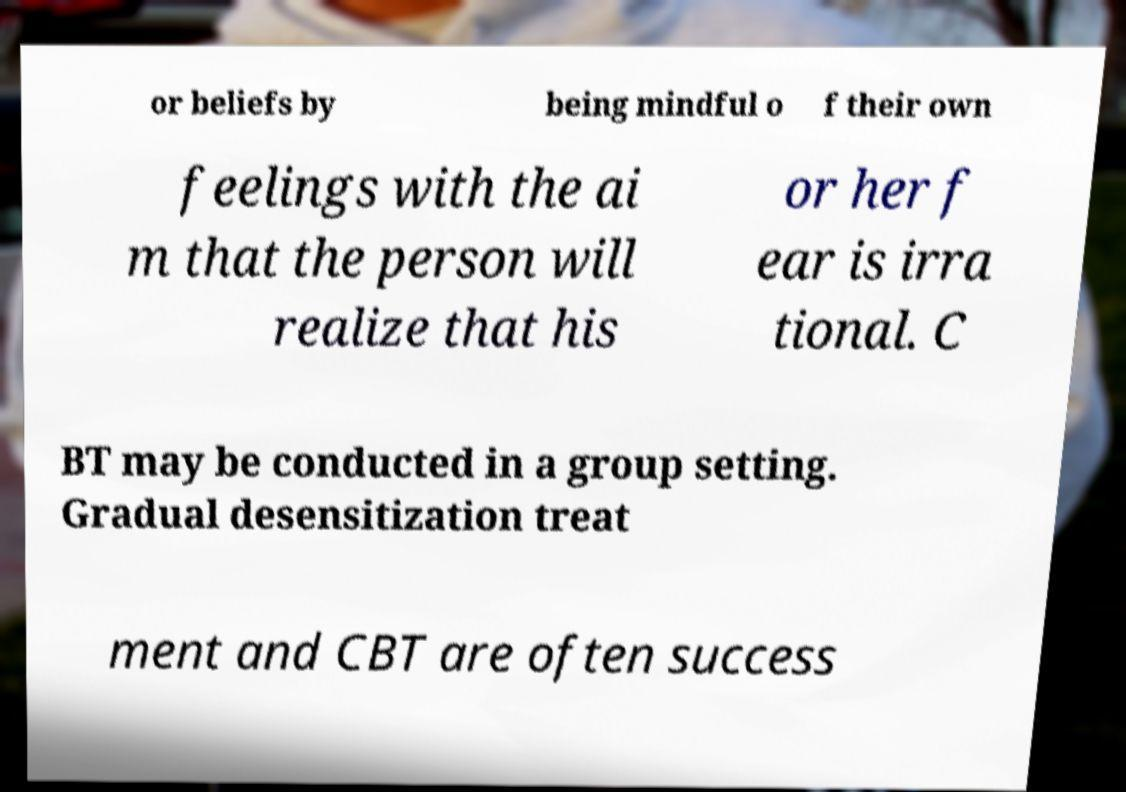Can you read and provide the text displayed in the image?This photo seems to have some interesting text. Can you extract and type it out for me? or beliefs by being mindful o f their own feelings with the ai m that the person will realize that his or her f ear is irra tional. C BT may be conducted in a group setting. Gradual desensitization treat ment and CBT are often success 